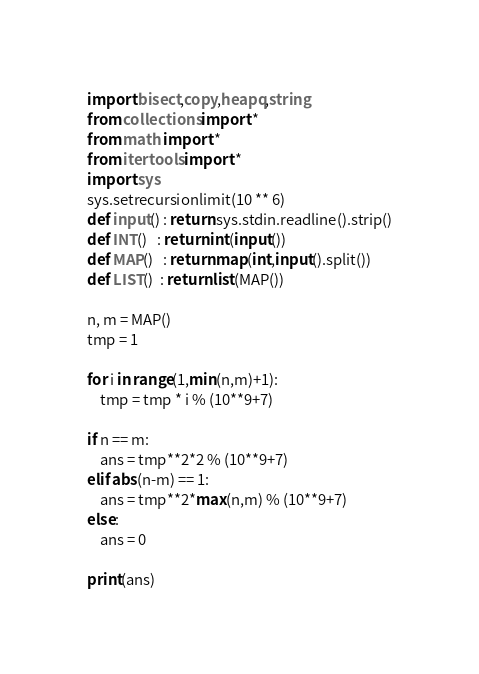Convert code to text. <code><loc_0><loc_0><loc_500><loc_500><_Python_>import bisect,copy,heapq,string
from collections import *
from math import *
from itertools import *
import sys
sys.setrecursionlimit(10 ** 6)
def input() : return sys.stdin.readline().strip()
def INT()   : return int(input())
def MAP()   : return map(int,input().split())
def LIST()  : return list(MAP())

n, m = MAP()
tmp = 1

for i in range(1,min(n,m)+1):
    tmp = tmp * i % (10**9+7)

if n == m:
    ans = tmp**2*2 % (10**9+7)
elif abs(n-m) == 1:
    ans = tmp**2*max(n,m) % (10**9+7)
else:
    ans = 0

print(ans)</code> 